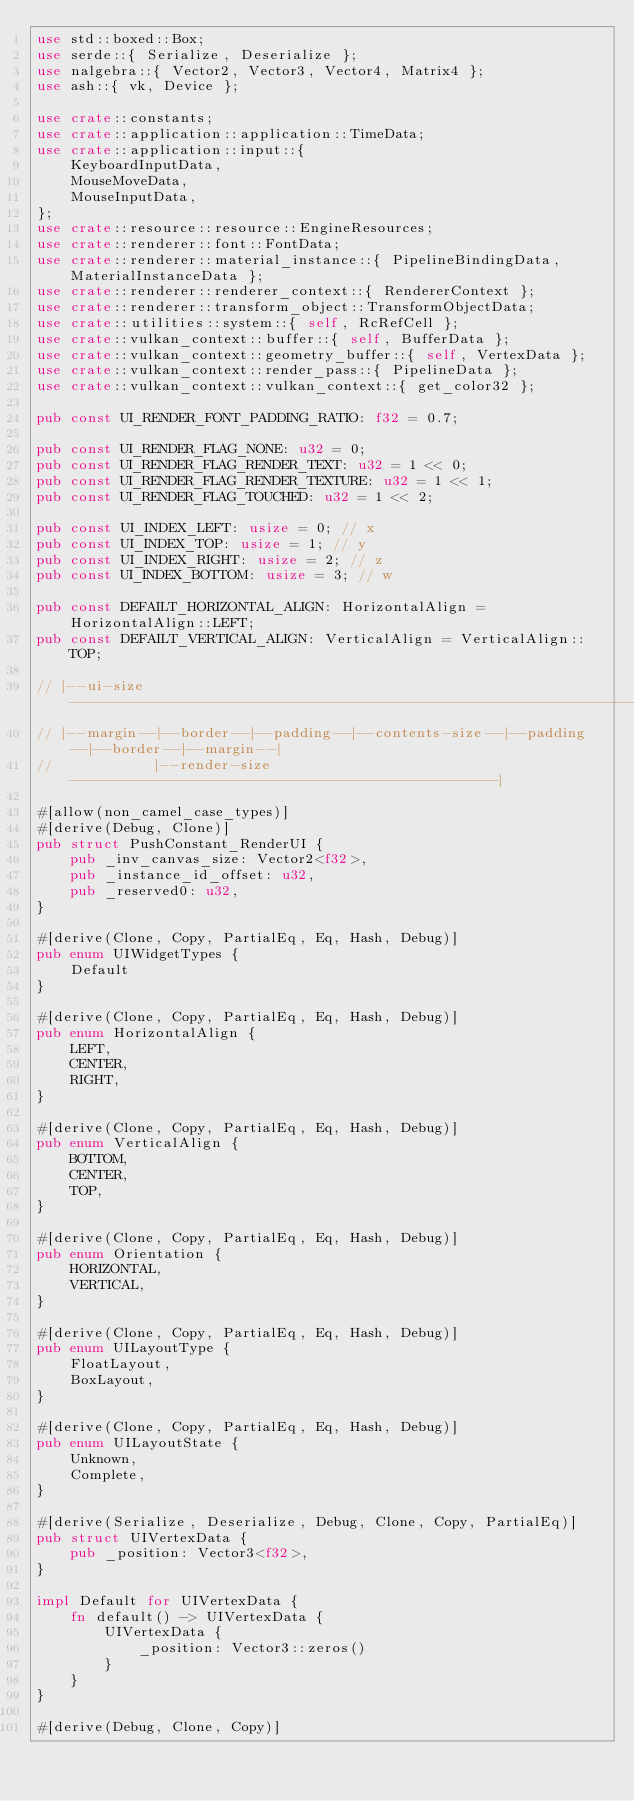Convert code to text. <code><loc_0><loc_0><loc_500><loc_500><_Rust_>use std::boxed::Box;
use serde::{ Serialize, Deserialize };
use nalgebra::{ Vector2, Vector3, Vector4, Matrix4 };
use ash::{ vk, Device };

use crate::constants;
use crate::application::application::TimeData;
use crate::application::input::{
    KeyboardInputData,
    MouseMoveData,
    MouseInputData,
};
use crate::resource::resource::EngineResources;
use crate::renderer::font::FontData;
use crate::renderer::material_instance::{ PipelineBindingData, MaterialInstanceData };
use crate::renderer::renderer_context::{ RendererContext };
use crate::renderer::transform_object::TransformObjectData;
use crate::utilities::system::{ self, RcRefCell };
use crate::vulkan_context::buffer::{ self, BufferData };
use crate::vulkan_context::geometry_buffer::{ self, VertexData };
use crate::vulkan_context::render_pass::{ PipelineData };
use crate::vulkan_context::vulkan_context::{ get_color32 };

pub const UI_RENDER_FONT_PADDING_RATIO: f32 = 0.7;

pub const UI_RENDER_FLAG_NONE: u32 = 0;
pub const UI_RENDER_FLAG_RENDER_TEXT: u32 = 1 << 0;
pub const UI_RENDER_FLAG_RENDER_TEXTURE: u32 = 1 << 1;
pub const UI_RENDER_FLAG_TOUCHED: u32 = 1 << 2;

pub const UI_INDEX_LEFT: usize = 0; // x
pub const UI_INDEX_TOP: usize = 1; // y
pub const UI_INDEX_RIGHT: usize = 2; // z
pub const UI_INDEX_BOTTOM: usize = 3; // w

pub const DEFAILT_HORIZONTAL_ALIGN: HorizontalAlign = HorizontalAlign::LEFT;
pub const DEFAILT_VERTICAL_ALIGN: VerticalAlign = VerticalAlign::TOP;

// |--ui-size----------------------------------------------------------------------------|
// |--margin--|--border--|--padding--|--contents-size--|--padding--|--border--|--margin--|
//            |--render-size--------------------------------------------------|

#[allow(non_camel_case_types)]
#[derive(Debug, Clone)]
pub struct PushConstant_RenderUI {
    pub _inv_canvas_size: Vector2<f32>,
    pub _instance_id_offset: u32,
    pub _reserved0: u32,
}

#[derive(Clone, Copy, PartialEq, Eq, Hash, Debug)]
pub enum UIWidgetTypes {
    Default
}

#[derive(Clone, Copy, PartialEq, Eq, Hash, Debug)]
pub enum HorizontalAlign {
    LEFT,
    CENTER,
    RIGHT,
}

#[derive(Clone, Copy, PartialEq, Eq, Hash, Debug)]
pub enum VerticalAlign {
    BOTTOM,
    CENTER,
    TOP,
}

#[derive(Clone, Copy, PartialEq, Eq, Hash, Debug)]
pub enum Orientation {
    HORIZONTAL,
    VERTICAL,
}

#[derive(Clone, Copy, PartialEq, Eq, Hash, Debug)]
pub enum UILayoutType {
    FloatLayout,
    BoxLayout,
}

#[derive(Clone, Copy, PartialEq, Eq, Hash, Debug)]
pub enum UILayoutState {
    Unknown,
    Complete,
}

#[derive(Serialize, Deserialize, Debug, Clone, Copy, PartialEq)]
pub struct UIVertexData {
    pub _position: Vector3<f32>,
}

impl Default for UIVertexData {
    fn default() -> UIVertexData {
        UIVertexData {
            _position: Vector3::zeros()
        }
    }
}

#[derive(Debug, Clone, Copy)]</code> 